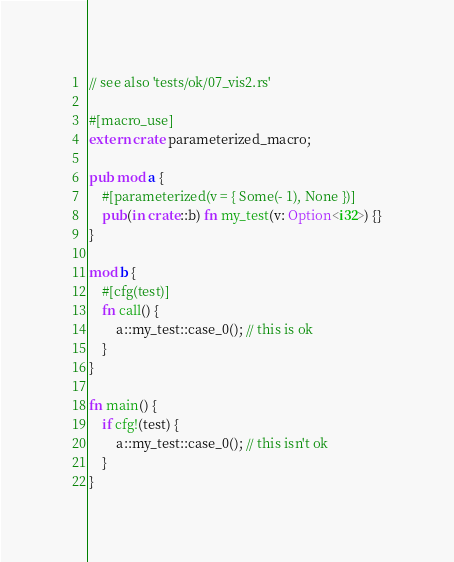<code> <loc_0><loc_0><loc_500><loc_500><_Rust_>// see also 'tests/ok/07_vis2.rs'

#[macro_use]
extern crate parameterized_macro;

pub mod a {
    #[parameterized(v = { Some(- 1), None })]
    pub(in crate::b) fn my_test(v: Option<i32>) {}
}

mod b {
    #[cfg(test)]
    fn call() {
        a::my_test::case_0(); // this is ok
    }
}

fn main() {
    if cfg!(test) {
        a::my_test::case_0(); // this isn't ok
    }
}
</code> 